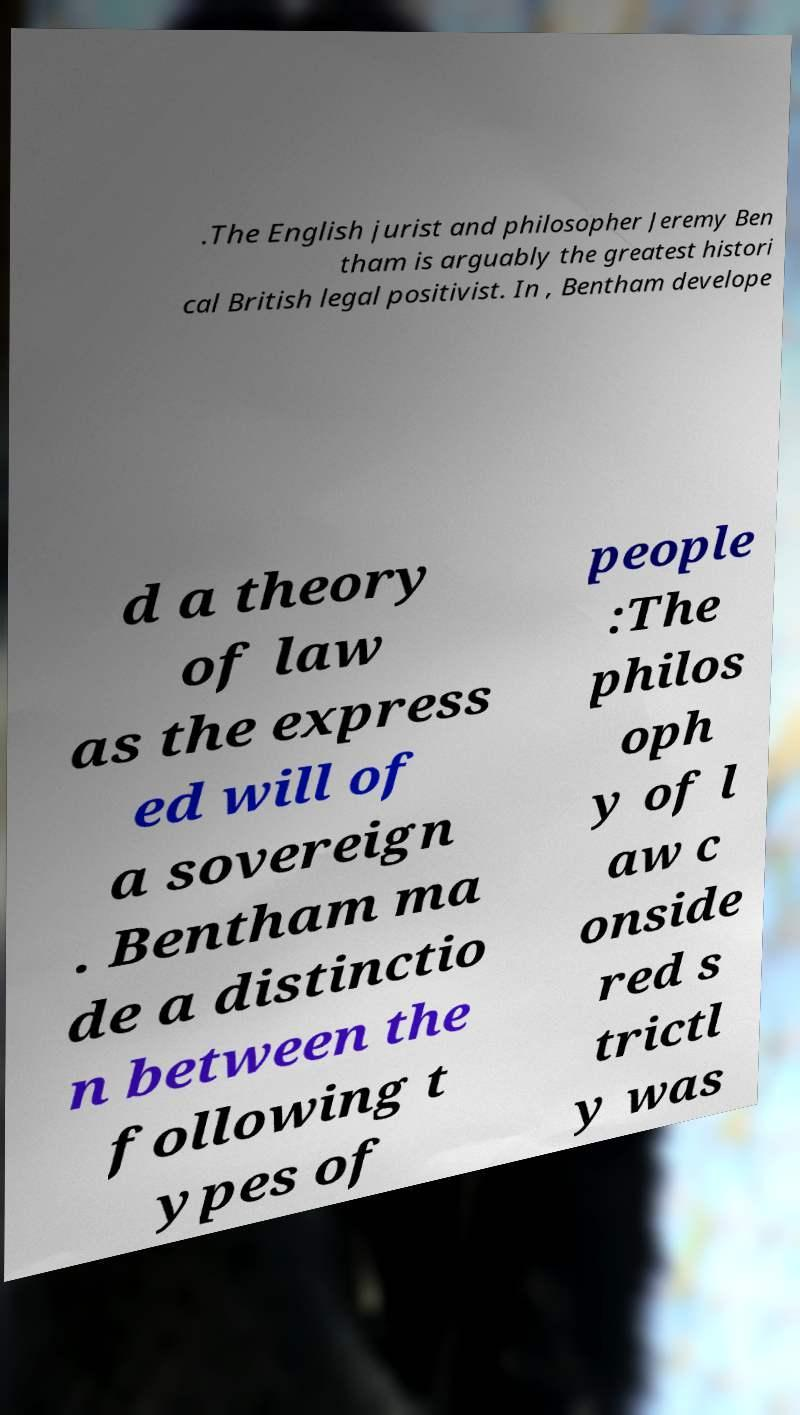Please read and relay the text visible in this image. What does it say? .The English jurist and philosopher Jeremy Ben tham is arguably the greatest histori cal British legal positivist. In , Bentham develope d a theory of law as the express ed will of a sovereign . Bentham ma de a distinctio n between the following t ypes of people :The philos oph y of l aw c onside red s trictl y was 